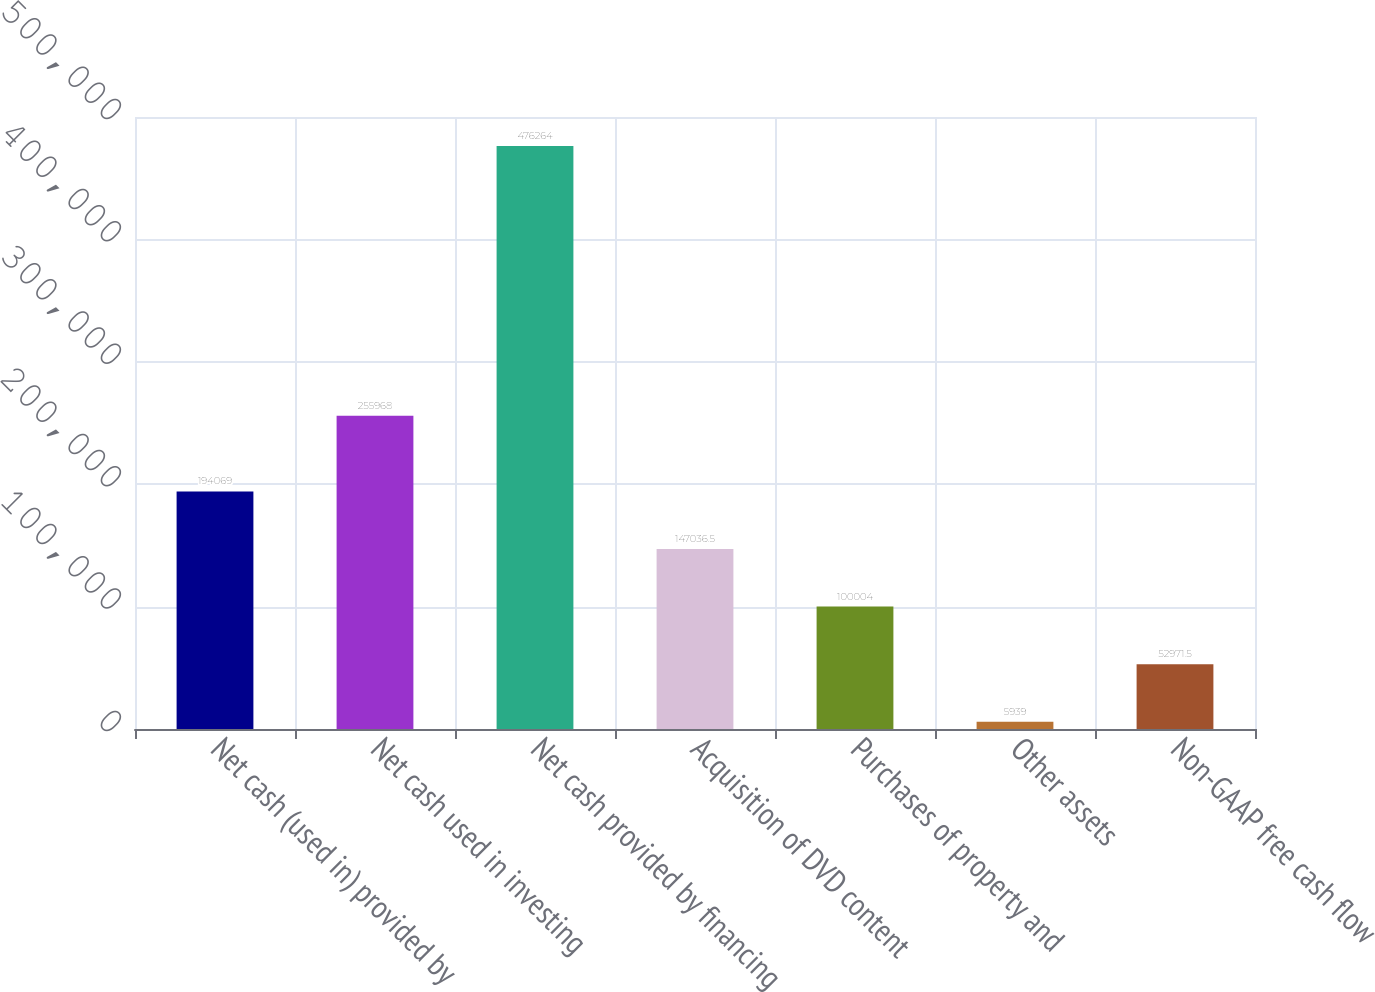Convert chart to OTSL. <chart><loc_0><loc_0><loc_500><loc_500><bar_chart><fcel>Net cash (used in) provided by<fcel>Net cash used in investing<fcel>Net cash provided by financing<fcel>Acquisition of DVD content<fcel>Purchases of property and<fcel>Other assets<fcel>Non-GAAP free cash flow<nl><fcel>194069<fcel>255968<fcel>476264<fcel>147036<fcel>100004<fcel>5939<fcel>52971.5<nl></chart> 